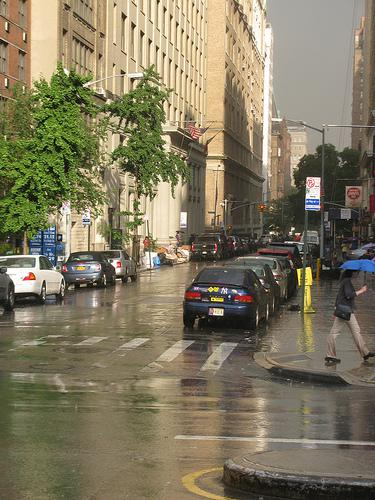Question: what is making the street shiny?
Choices:
A. An oil slick.
B. Ice.
C. Glitter left from the parade.
D. Rain.
Answer with the letter. Answer: D Question: when will the woman close the umbrella?
Choices:
A. When she goes indoors.
B. When it stops raining.
C. When she gets on the bus.
D. When she gets into the cab.
Answer with the letter. Answer: B Question: what color is the sky?
Choices:
A. Dark blue.
B. Pale blue.
C. A deep grey.
D. Pink and red.
Answer with the letter. Answer: C Question: why is the woman using an umbrella?
Choices:
A. It is very sunny.
B. The flock of birds are making droppings.
C. It is raining.
D. She is fighting off attackers.
Answer with the letter. Answer: C Question: who is looking at this scene?
Choices:
A. The police officer.
B. The photographer.
C. The movie director.
D. The firefighters.
Answer with the letter. Answer: B 